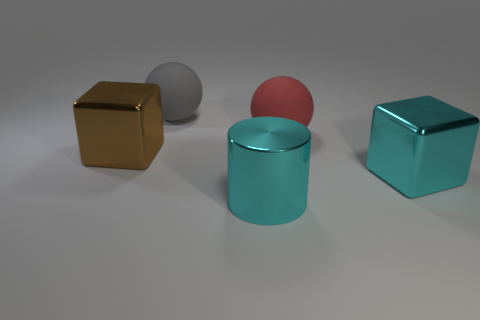Add 3 cyan things. How many objects exist? 8 Subtract all gray spheres. How many spheres are left? 1 Subtract all cylinders. How many objects are left? 4 Subtract 1 balls. How many balls are left? 1 Subtract all cyan blocks. Subtract all purple balls. How many blocks are left? 1 Subtract all cyan spheres. How many red cubes are left? 0 Subtract all gray balls. Subtract all big red things. How many objects are left? 3 Add 1 cubes. How many cubes are left? 3 Add 2 big brown things. How many big brown things exist? 3 Subtract 0 blue blocks. How many objects are left? 5 